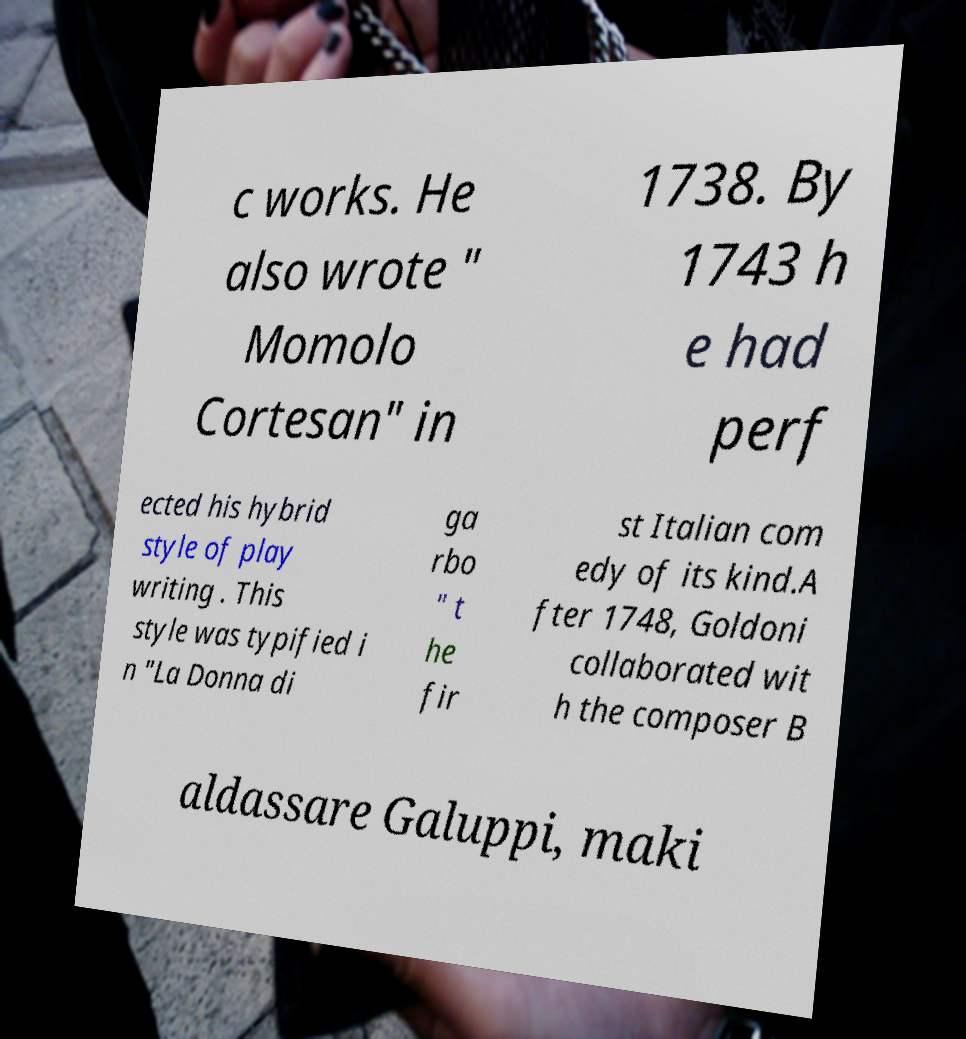Can you accurately transcribe the text from the provided image for me? c works. He also wrote " Momolo Cortesan" in 1738. By 1743 h e had perf ected his hybrid style of play writing . This style was typified i n "La Donna di ga rbo " t he fir st Italian com edy of its kind.A fter 1748, Goldoni collaborated wit h the composer B aldassare Galuppi, maki 